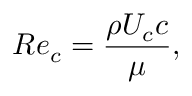<formula> <loc_0><loc_0><loc_500><loc_500>R e _ { c } = \frac { \rho U _ { c } c } { \mu } ,</formula> 